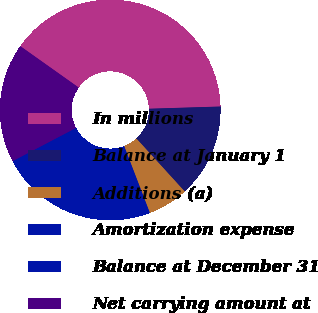<chart> <loc_0><loc_0><loc_500><loc_500><pie_chart><fcel>In millions<fcel>Balance at January 1<fcel>Additions (a)<fcel>Amortization expense<fcel>Balance at December 31<fcel>Net carrying amount at<nl><fcel>39.69%<fcel>13.72%<fcel>5.93%<fcel>1.88%<fcel>21.28%<fcel>17.5%<nl></chart> 